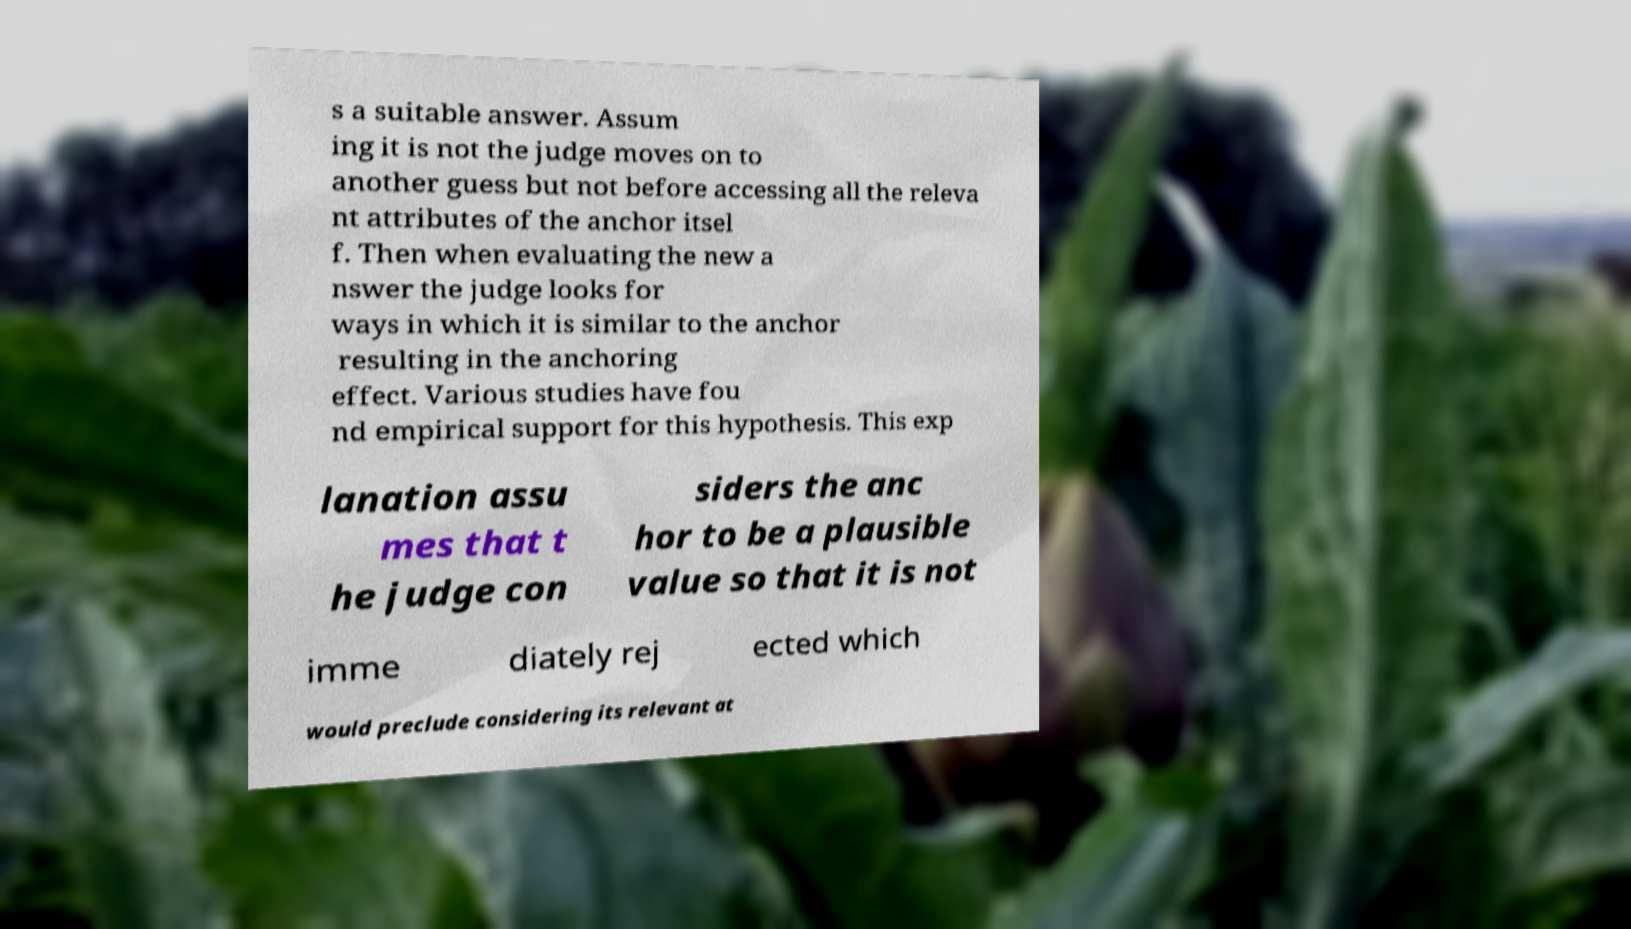What messages or text are displayed in this image? I need them in a readable, typed format. s a suitable answer. Assum ing it is not the judge moves on to another guess but not before accessing all the releva nt attributes of the anchor itsel f. Then when evaluating the new a nswer the judge looks for ways in which it is similar to the anchor resulting in the anchoring effect. Various studies have fou nd empirical support for this hypothesis. This exp lanation assu mes that t he judge con siders the anc hor to be a plausible value so that it is not imme diately rej ected which would preclude considering its relevant at 